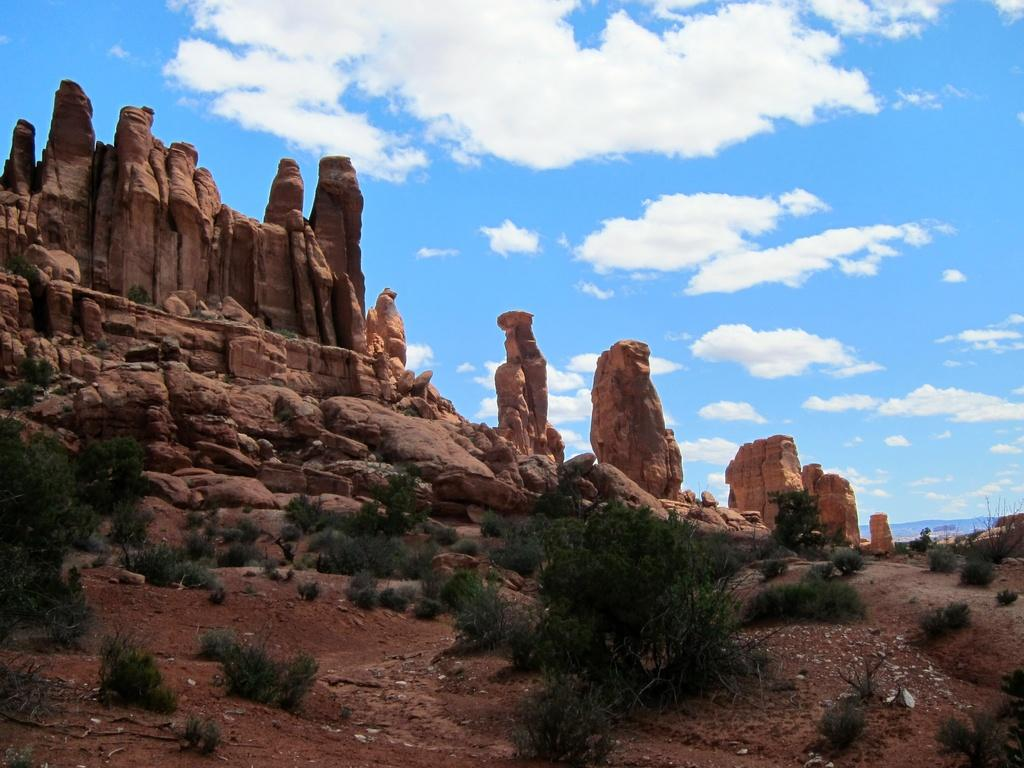What type of living organisms can be seen in the image? Plants can be seen in the image. What else is present in the image besides plants? There are rocks in the image. What can be seen in the background of the image? The sky is visible in the background of the image. What is the condition of the sky in the image? Clouds are present in the sky. What type of parcel is being delivered to the plants in the image? There is no parcel present in the image, and no indication of a delivery being made. 